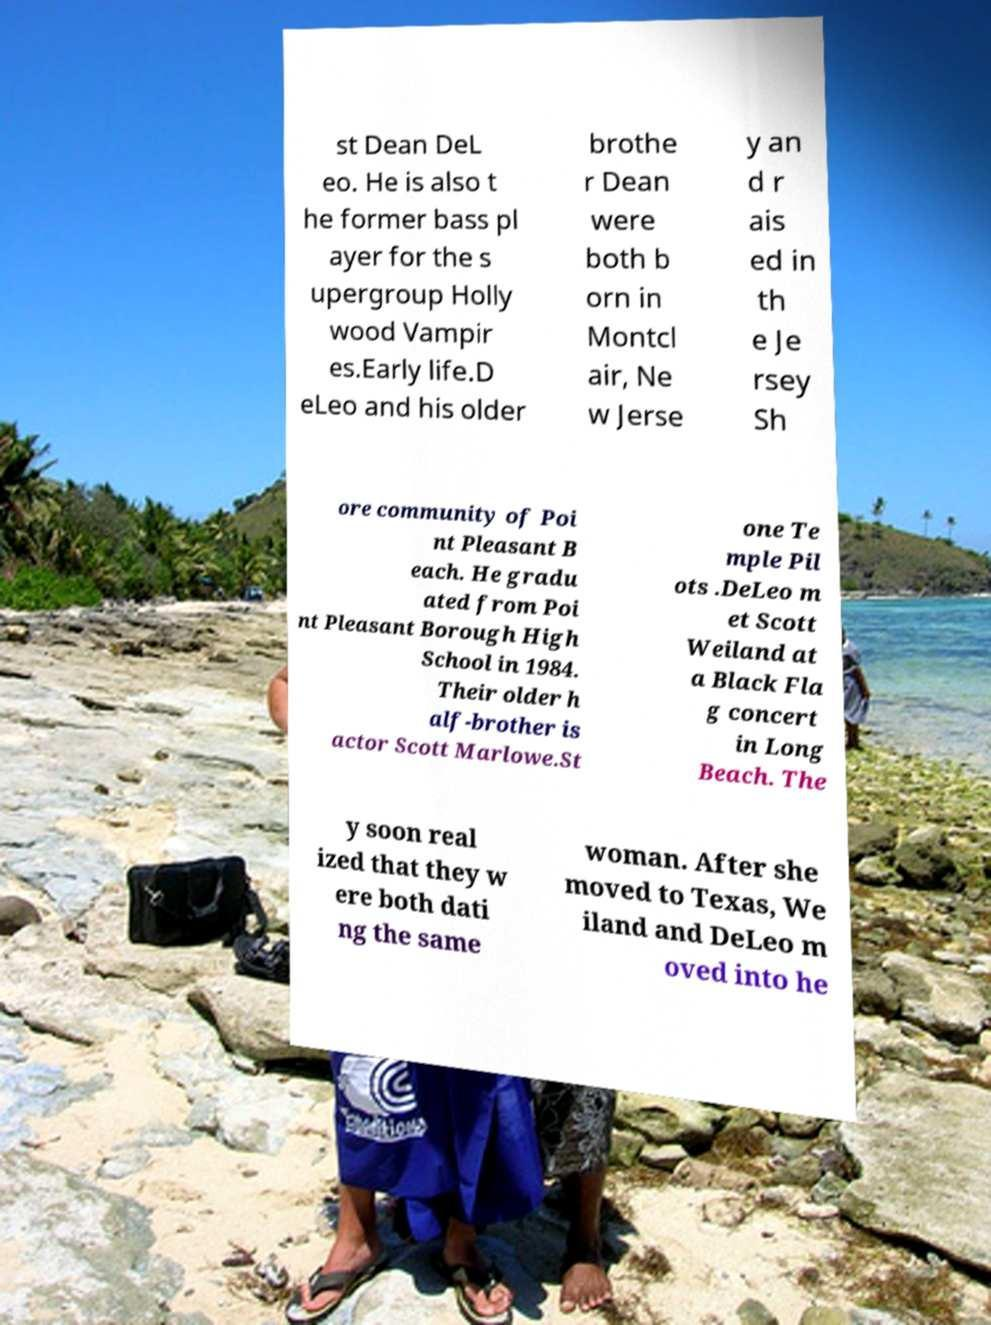Could you extract and type out the text from this image? st Dean DeL eo. He is also t he former bass pl ayer for the s upergroup Holly wood Vampir es.Early life.D eLeo and his older brothe r Dean were both b orn in Montcl air, Ne w Jerse y an d r ais ed in th e Je rsey Sh ore community of Poi nt Pleasant B each. He gradu ated from Poi nt Pleasant Borough High School in 1984. Their older h alf-brother is actor Scott Marlowe.St one Te mple Pil ots .DeLeo m et Scott Weiland at a Black Fla g concert in Long Beach. The y soon real ized that they w ere both dati ng the same woman. After she moved to Texas, We iland and DeLeo m oved into he 